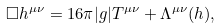Convert formula to latex. <formula><loc_0><loc_0><loc_500><loc_500>\Box h ^ { \mu \nu } = { 1 6 \pi } | g | T ^ { \mu \nu } + \Lambda ^ { \mu \nu } ( h ) ,</formula> 